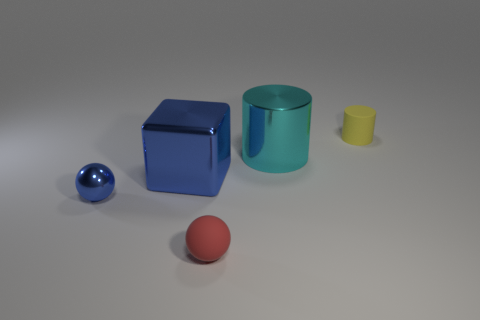Add 1 tiny red matte spheres. How many objects exist? 6 Subtract all cubes. How many objects are left? 4 Subtract 1 blue balls. How many objects are left? 4 Subtract all blue metallic blocks. Subtract all tiny rubber objects. How many objects are left? 2 Add 5 large cubes. How many large cubes are left? 6 Add 1 small metallic objects. How many small metallic objects exist? 2 